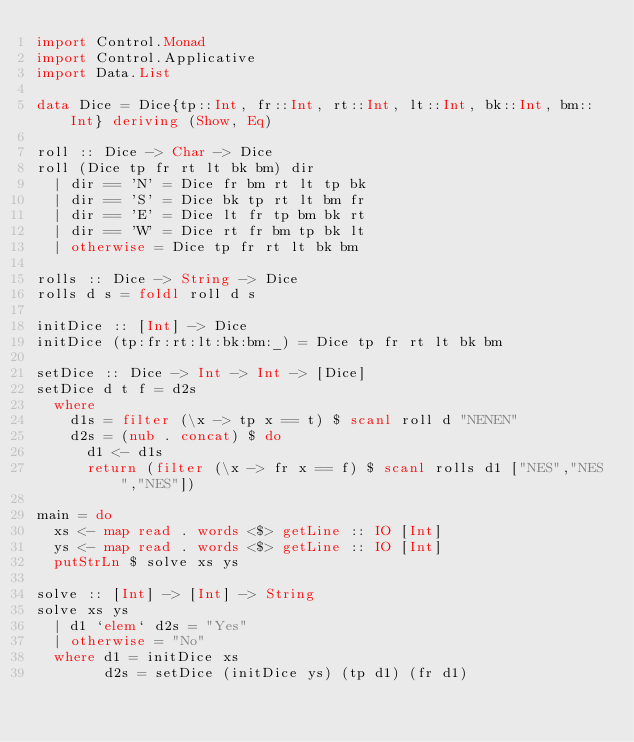<code> <loc_0><loc_0><loc_500><loc_500><_Haskell_>import Control.Monad
import Control.Applicative
import Data.List

data Dice = Dice{tp::Int, fr::Int, rt::Int, lt::Int, bk::Int, bm::Int} deriving (Show, Eq)

roll :: Dice -> Char -> Dice
roll (Dice tp fr rt lt bk bm) dir
  | dir == 'N' = Dice fr bm rt lt tp bk
  | dir == 'S' = Dice bk tp rt lt bm fr
  | dir == 'E' = Dice lt fr tp bm bk rt
  | dir == 'W' = Dice rt fr bm tp bk lt
  | otherwise = Dice tp fr rt lt bk bm

rolls :: Dice -> String -> Dice
rolls d s = foldl roll d s

initDice :: [Int] -> Dice
initDice (tp:fr:rt:lt:bk:bm:_) = Dice tp fr rt lt bk bm

setDice :: Dice -> Int -> Int -> [Dice]
setDice d t f = d2s
  where
    d1s = filter (\x -> tp x == t) $ scanl roll d "NENEN"
    d2s = (nub . concat) $ do
      d1 <- d1s
      return (filter (\x -> fr x == f) $ scanl rolls d1 ["NES","NES","NES"])

main = do
  xs <- map read . words <$> getLine :: IO [Int]
  ys <- map read . words <$> getLine :: IO [Int]
  putStrLn $ solve xs ys

solve :: [Int] -> [Int] -> String
solve xs ys
  | d1 `elem` d2s = "Yes"
  | otherwise = "No"
  where d1 = initDice xs
        d2s = setDice (initDice ys) (tp d1) (fr d1)</code> 